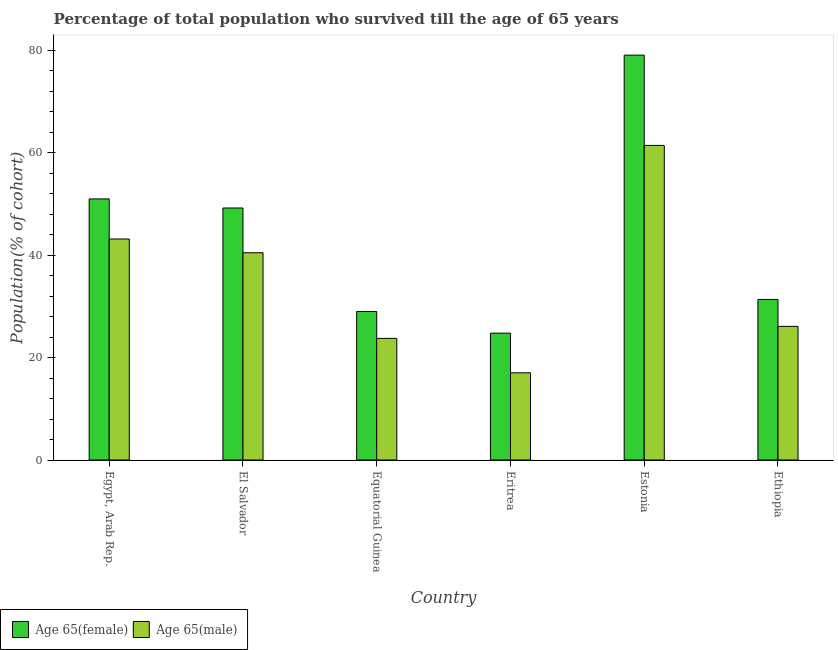How many different coloured bars are there?
Ensure brevity in your answer.  2. How many groups of bars are there?
Your answer should be compact. 6. Are the number of bars per tick equal to the number of legend labels?
Provide a succinct answer. Yes. What is the label of the 5th group of bars from the left?
Offer a terse response. Estonia. In how many cases, is the number of bars for a given country not equal to the number of legend labels?
Ensure brevity in your answer.  0. What is the percentage of female population who survived till age of 65 in Estonia?
Your response must be concise. 79.08. Across all countries, what is the maximum percentage of female population who survived till age of 65?
Offer a terse response. 79.08. Across all countries, what is the minimum percentage of male population who survived till age of 65?
Make the answer very short. 17.03. In which country was the percentage of female population who survived till age of 65 maximum?
Offer a very short reply. Estonia. In which country was the percentage of female population who survived till age of 65 minimum?
Your response must be concise. Eritrea. What is the total percentage of female population who survived till age of 65 in the graph?
Your answer should be compact. 264.45. What is the difference between the percentage of female population who survived till age of 65 in Equatorial Guinea and that in Eritrea?
Ensure brevity in your answer.  4.23. What is the difference between the percentage of female population who survived till age of 65 in Equatorial Guinea and the percentage of male population who survived till age of 65 in El Salvador?
Ensure brevity in your answer.  -11.47. What is the average percentage of female population who survived till age of 65 per country?
Offer a very short reply. 44.08. What is the difference between the percentage of female population who survived till age of 65 and percentage of male population who survived till age of 65 in Equatorial Guinea?
Keep it short and to the point. 5.25. In how many countries, is the percentage of female population who survived till age of 65 greater than 48 %?
Offer a terse response. 3. What is the ratio of the percentage of male population who survived till age of 65 in Egypt, Arab Rep. to that in El Salvador?
Provide a succinct answer. 1.07. What is the difference between the highest and the second highest percentage of female population who survived till age of 65?
Your response must be concise. 28.09. What is the difference between the highest and the lowest percentage of female population who survived till age of 65?
Your answer should be compact. 54.3. Is the sum of the percentage of male population who survived till age of 65 in Estonia and Ethiopia greater than the maximum percentage of female population who survived till age of 65 across all countries?
Offer a very short reply. Yes. What does the 1st bar from the left in Ethiopia represents?
Offer a very short reply. Age 65(female). What does the 1st bar from the right in Egypt, Arab Rep. represents?
Make the answer very short. Age 65(male). Are the values on the major ticks of Y-axis written in scientific E-notation?
Provide a succinct answer. No. Does the graph contain any zero values?
Your answer should be compact. No. Does the graph contain grids?
Make the answer very short. No. Where does the legend appear in the graph?
Make the answer very short. Bottom left. How many legend labels are there?
Make the answer very short. 2. What is the title of the graph?
Give a very brief answer. Percentage of total population who survived till the age of 65 years. Does "Travel Items" appear as one of the legend labels in the graph?
Provide a short and direct response. No. What is the label or title of the Y-axis?
Your answer should be very brief. Population(% of cohort). What is the Population(% of cohort) in Age 65(female) in Egypt, Arab Rep.?
Give a very brief answer. 51. What is the Population(% of cohort) of Age 65(male) in Egypt, Arab Rep.?
Your answer should be very brief. 43.17. What is the Population(% of cohort) of Age 65(female) in El Salvador?
Make the answer very short. 49.22. What is the Population(% of cohort) in Age 65(male) in El Salvador?
Offer a very short reply. 40.48. What is the Population(% of cohort) of Age 65(female) in Equatorial Guinea?
Provide a short and direct response. 29.01. What is the Population(% of cohort) of Age 65(male) in Equatorial Guinea?
Provide a short and direct response. 23.76. What is the Population(% of cohort) of Age 65(female) in Eritrea?
Your response must be concise. 24.78. What is the Population(% of cohort) in Age 65(male) in Eritrea?
Keep it short and to the point. 17.03. What is the Population(% of cohort) in Age 65(female) in Estonia?
Keep it short and to the point. 79.08. What is the Population(% of cohort) in Age 65(male) in Estonia?
Ensure brevity in your answer.  61.45. What is the Population(% of cohort) in Age 65(female) in Ethiopia?
Give a very brief answer. 31.36. What is the Population(% of cohort) of Age 65(male) in Ethiopia?
Give a very brief answer. 26.1. Across all countries, what is the maximum Population(% of cohort) in Age 65(female)?
Your answer should be compact. 79.08. Across all countries, what is the maximum Population(% of cohort) in Age 65(male)?
Your answer should be very brief. 61.45. Across all countries, what is the minimum Population(% of cohort) of Age 65(female)?
Provide a succinct answer. 24.78. Across all countries, what is the minimum Population(% of cohort) in Age 65(male)?
Provide a short and direct response. 17.03. What is the total Population(% of cohort) in Age 65(female) in the graph?
Provide a short and direct response. 264.45. What is the total Population(% of cohort) in Age 65(male) in the graph?
Give a very brief answer. 211.99. What is the difference between the Population(% of cohort) in Age 65(female) in Egypt, Arab Rep. and that in El Salvador?
Offer a terse response. 1.77. What is the difference between the Population(% of cohort) of Age 65(male) in Egypt, Arab Rep. and that in El Salvador?
Provide a short and direct response. 2.69. What is the difference between the Population(% of cohort) of Age 65(female) in Egypt, Arab Rep. and that in Equatorial Guinea?
Offer a terse response. 21.99. What is the difference between the Population(% of cohort) of Age 65(male) in Egypt, Arab Rep. and that in Equatorial Guinea?
Offer a very short reply. 19.41. What is the difference between the Population(% of cohort) of Age 65(female) in Egypt, Arab Rep. and that in Eritrea?
Ensure brevity in your answer.  26.22. What is the difference between the Population(% of cohort) in Age 65(male) in Egypt, Arab Rep. and that in Eritrea?
Provide a short and direct response. 26.14. What is the difference between the Population(% of cohort) of Age 65(female) in Egypt, Arab Rep. and that in Estonia?
Keep it short and to the point. -28.09. What is the difference between the Population(% of cohort) of Age 65(male) in Egypt, Arab Rep. and that in Estonia?
Provide a short and direct response. -18.28. What is the difference between the Population(% of cohort) in Age 65(female) in Egypt, Arab Rep. and that in Ethiopia?
Provide a succinct answer. 19.64. What is the difference between the Population(% of cohort) in Age 65(male) in Egypt, Arab Rep. and that in Ethiopia?
Keep it short and to the point. 17.07. What is the difference between the Population(% of cohort) of Age 65(female) in El Salvador and that in Equatorial Guinea?
Your answer should be compact. 20.21. What is the difference between the Population(% of cohort) in Age 65(male) in El Salvador and that in Equatorial Guinea?
Your answer should be compact. 16.72. What is the difference between the Population(% of cohort) of Age 65(female) in El Salvador and that in Eritrea?
Keep it short and to the point. 24.44. What is the difference between the Population(% of cohort) of Age 65(male) in El Salvador and that in Eritrea?
Ensure brevity in your answer.  23.45. What is the difference between the Population(% of cohort) in Age 65(female) in El Salvador and that in Estonia?
Your response must be concise. -29.86. What is the difference between the Population(% of cohort) of Age 65(male) in El Salvador and that in Estonia?
Make the answer very short. -20.96. What is the difference between the Population(% of cohort) in Age 65(female) in El Salvador and that in Ethiopia?
Your answer should be very brief. 17.86. What is the difference between the Population(% of cohort) of Age 65(male) in El Salvador and that in Ethiopia?
Offer a very short reply. 14.38. What is the difference between the Population(% of cohort) in Age 65(female) in Equatorial Guinea and that in Eritrea?
Provide a short and direct response. 4.23. What is the difference between the Population(% of cohort) of Age 65(male) in Equatorial Guinea and that in Eritrea?
Your answer should be compact. 6.73. What is the difference between the Population(% of cohort) of Age 65(female) in Equatorial Guinea and that in Estonia?
Your answer should be compact. -50.07. What is the difference between the Population(% of cohort) in Age 65(male) in Equatorial Guinea and that in Estonia?
Offer a very short reply. -37.69. What is the difference between the Population(% of cohort) of Age 65(female) in Equatorial Guinea and that in Ethiopia?
Give a very brief answer. -2.35. What is the difference between the Population(% of cohort) in Age 65(male) in Equatorial Guinea and that in Ethiopia?
Offer a terse response. -2.34. What is the difference between the Population(% of cohort) of Age 65(female) in Eritrea and that in Estonia?
Give a very brief answer. -54.3. What is the difference between the Population(% of cohort) of Age 65(male) in Eritrea and that in Estonia?
Provide a short and direct response. -44.41. What is the difference between the Population(% of cohort) of Age 65(female) in Eritrea and that in Ethiopia?
Make the answer very short. -6.58. What is the difference between the Population(% of cohort) of Age 65(male) in Eritrea and that in Ethiopia?
Your answer should be compact. -9.07. What is the difference between the Population(% of cohort) of Age 65(female) in Estonia and that in Ethiopia?
Your response must be concise. 47.72. What is the difference between the Population(% of cohort) in Age 65(male) in Estonia and that in Ethiopia?
Offer a very short reply. 35.35. What is the difference between the Population(% of cohort) of Age 65(female) in Egypt, Arab Rep. and the Population(% of cohort) of Age 65(male) in El Salvador?
Provide a short and direct response. 10.52. What is the difference between the Population(% of cohort) in Age 65(female) in Egypt, Arab Rep. and the Population(% of cohort) in Age 65(male) in Equatorial Guinea?
Provide a succinct answer. 27.24. What is the difference between the Population(% of cohort) of Age 65(female) in Egypt, Arab Rep. and the Population(% of cohort) of Age 65(male) in Eritrea?
Make the answer very short. 33.97. What is the difference between the Population(% of cohort) in Age 65(female) in Egypt, Arab Rep. and the Population(% of cohort) in Age 65(male) in Estonia?
Provide a short and direct response. -10.45. What is the difference between the Population(% of cohort) of Age 65(female) in Egypt, Arab Rep. and the Population(% of cohort) of Age 65(male) in Ethiopia?
Provide a succinct answer. 24.9. What is the difference between the Population(% of cohort) of Age 65(female) in El Salvador and the Population(% of cohort) of Age 65(male) in Equatorial Guinea?
Your answer should be compact. 25.46. What is the difference between the Population(% of cohort) in Age 65(female) in El Salvador and the Population(% of cohort) in Age 65(male) in Eritrea?
Your answer should be very brief. 32.19. What is the difference between the Population(% of cohort) in Age 65(female) in El Salvador and the Population(% of cohort) in Age 65(male) in Estonia?
Provide a short and direct response. -12.22. What is the difference between the Population(% of cohort) in Age 65(female) in El Salvador and the Population(% of cohort) in Age 65(male) in Ethiopia?
Your answer should be compact. 23.12. What is the difference between the Population(% of cohort) of Age 65(female) in Equatorial Guinea and the Population(% of cohort) of Age 65(male) in Eritrea?
Ensure brevity in your answer.  11.98. What is the difference between the Population(% of cohort) in Age 65(female) in Equatorial Guinea and the Population(% of cohort) in Age 65(male) in Estonia?
Provide a short and direct response. -32.43. What is the difference between the Population(% of cohort) of Age 65(female) in Equatorial Guinea and the Population(% of cohort) of Age 65(male) in Ethiopia?
Your response must be concise. 2.91. What is the difference between the Population(% of cohort) of Age 65(female) in Eritrea and the Population(% of cohort) of Age 65(male) in Estonia?
Keep it short and to the point. -36.67. What is the difference between the Population(% of cohort) of Age 65(female) in Eritrea and the Population(% of cohort) of Age 65(male) in Ethiopia?
Provide a short and direct response. -1.32. What is the difference between the Population(% of cohort) in Age 65(female) in Estonia and the Population(% of cohort) in Age 65(male) in Ethiopia?
Provide a succinct answer. 52.98. What is the average Population(% of cohort) in Age 65(female) per country?
Your answer should be very brief. 44.08. What is the average Population(% of cohort) of Age 65(male) per country?
Make the answer very short. 35.33. What is the difference between the Population(% of cohort) in Age 65(female) and Population(% of cohort) in Age 65(male) in Egypt, Arab Rep.?
Provide a succinct answer. 7.83. What is the difference between the Population(% of cohort) in Age 65(female) and Population(% of cohort) in Age 65(male) in El Salvador?
Keep it short and to the point. 8.74. What is the difference between the Population(% of cohort) in Age 65(female) and Population(% of cohort) in Age 65(male) in Equatorial Guinea?
Your answer should be compact. 5.25. What is the difference between the Population(% of cohort) in Age 65(female) and Population(% of cohort) in Age 65(male) in Eritrea?
Make the answer very short. 7.75. What is the difference between the Population(% of cohort) of Age 65(female) and Population(% of cohort) of Age 65(male) in Estonia?
Offer a very short reply. 17.64. What is the difference between the Population(% of cohort) in Age 65(female) and Population(% of cohort) in Age 65(male) in Ethiopia?
Give a very brief answer. 5.26. What is the ratio of the Population(% of cohort) in Age 65(female) in Egypt, Arab Rep. to that in El Salvador?
Keep it short and to the point. 1.04. What is the ratio of the Population(% of cohort) of Age 65(male) in Egypt, Arab Rep. to that in El Salvador?
Provide a succinct answer. 1.07. What is the ratio of the Population(% of cohort) of Age 65(female) in Egypt, Arab Rep. to that in Equatorial Guinea?
Your response must be concise. 1.76. What is the ratio of the Population(% of cohort) of Age 65(male) in Egypt, Arab Rep. to that in Equatorial Guinea?
Make the answer very short. 1.82. What is the ratio of the Population(% of cohort) in Age 65(female) in Egypt, Arab Rep. to that in Eritrea?
Your answer should be compact. 2.06. What is the ratio of the Population(% of cohort) in Age 65(male) in Egypt, Arab Rep. to that in Eritrea?
Give a very brief answer. 2.53. What is the ratio of the Population(% of cohort) of Age 65(female) in Egypt, Arab Rep. to that in Estonia?
Give a very brief answer. 0.64. What is the ratio of the Population(% of cohort) in Age 65(male) in Egypt, Arab Rep. to that in Estonia?
Give a very brief answer. 0.7. What is the ratio of the Population(% of cohort) of Age 65(female) in Egypt, Arab Rep. to that in Ethiopia?
Your answer should be very brief. 1.63. What is the ratio of the Population(% of cohort) in Age 65(male) in Egypt, Arab Rep. to that in Ethiopia?
Your answer should be very brief. 1.65. What is the ratio of the Population(% of cohort) of Age 65(female) in El Salvador to that in Equatorial Guinea?
Your answer should be very brief. 1.7. What is the ratio of the Population(% of cohort) of Age 65(male) in El Salvador to that in Equatorial Guinea?
Provide a short and direct response. 1.7. What is the ratio of the Population(% of cohort) in Age 65(female) in El Salvador to that in Eritrea?
Ensure brevity in your answer.  1.99. What is the ratio of the Population(% of cohort) in Age 65(male) in El Salvador to that in Eritrea?
Make the answer very short. 2.38. What is the ratio of the Population(% of cohort) in Age 65(female) in El Salvador to that in Estonia?
Your response must be concise. 0.62. What is the ratio of the Population(% of cohort) in Age 65(male) in El Salvador to that in Estonia?
Ensure brevity in your answer.  0.66. What is the ratio of the Population(% of cohort) of Age 65(female) in El Salvador to that in Ethiopia?
Make the answer very short. 1.57. What is the ratio of the Population(% of cohort) of Age 65(male) in El Salvador to that in Ethiopia?
Offer a very short reply. 1.55. What is the ratio of the Population(% of cohort) of Age 65(female) in Equatorial Guinea to that in Eritrea?
Provide a short and direct response. 1.17. What is the ratio of the Population(% of cohort) of Age 65(male) in Equatorial Guinea to that in Eritrea?
Give a very brief answer. 1.39. What is the ratio of the Population(% of cohort) of Age 65(female) in Equatorial Guinea to that in Estonia?
Keep it short and to the point. 0.37. What is the ratio of the Population(% of cohort) of Age 65(male) in Equatorial Guinea to that in Estonia?
Make the answer very short. 0.39. What is the ratio of the Population(% of cohort) in Age 65(female) in Equatorial Guinea to that in Ethiopia?
Offer a very short reply. 0.93. What is the ratio of the Population(% of cohort) in Age 65(male) in Equatorial Guinea to that in Ethiopia?
Offer a very short reply. 0.91. What is the ratio of the Population(% of cohort) of Age 65(female) in Eritrea to that in Estonia?
Provide a succinct answer. 0.31. What is the ratio of the Population(% of cohort) of Age 65(male) in Eritrea to that in Estonia?
Give a very brief answer. 0.28. What is the ratio of the Population(% of cohort) in Age 65(female) in Eritrea to that in Ethiopia?
Ensure brevity in your answer.  0.79. What is the ratio of the Population(% of cohort) of Age 65(male) in Eritrea to that in Ethiopia?
Offer a terse response. 0.65. What is the ratio of the Population(% of cohort) of Age 65(female) in Estonia to that in Ethiopia?
Your answer should be very brief. 2.52. What is the ratio of the Population(% of cohort) of Age 65(male) in Estonia to that in Ethiopia?
Ensure brevity in your answer.  2.35. What is the difference between the highest and the second highest Population(% of cohort) of Age 65(female)?
Your answer should be very brief. 28.09. What is the difference between the highest and the second highest Population(% of cohort) in Age 65(male)?
Make the answer very short. 18.28. What is the difference between the highest and the lowest Population(% of cohort) in Age 65(female)?
Your answer should be compact. 54.3. What is the difference between the highest and the lowest Population(% of cohort) in Age 65(male)?
Keep it short and to the point. 44.41. 